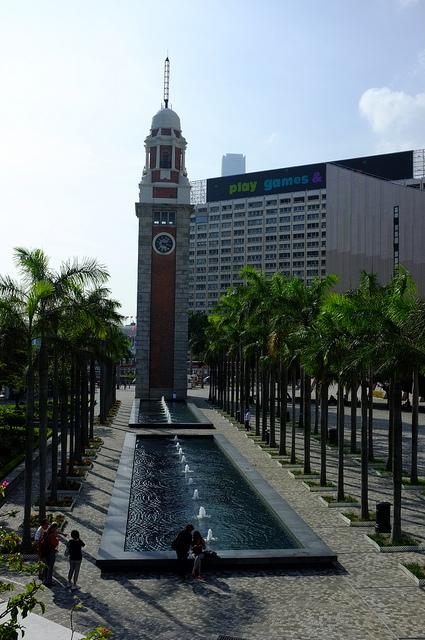What does the banner say?
Answer briefly. Play games. How many trees are there?
Short answer required. 30. Is there a clock in the picture?
Give a very brief answer. Yes. Are there any palm trees in this picture?
Be succinct. Yes. 